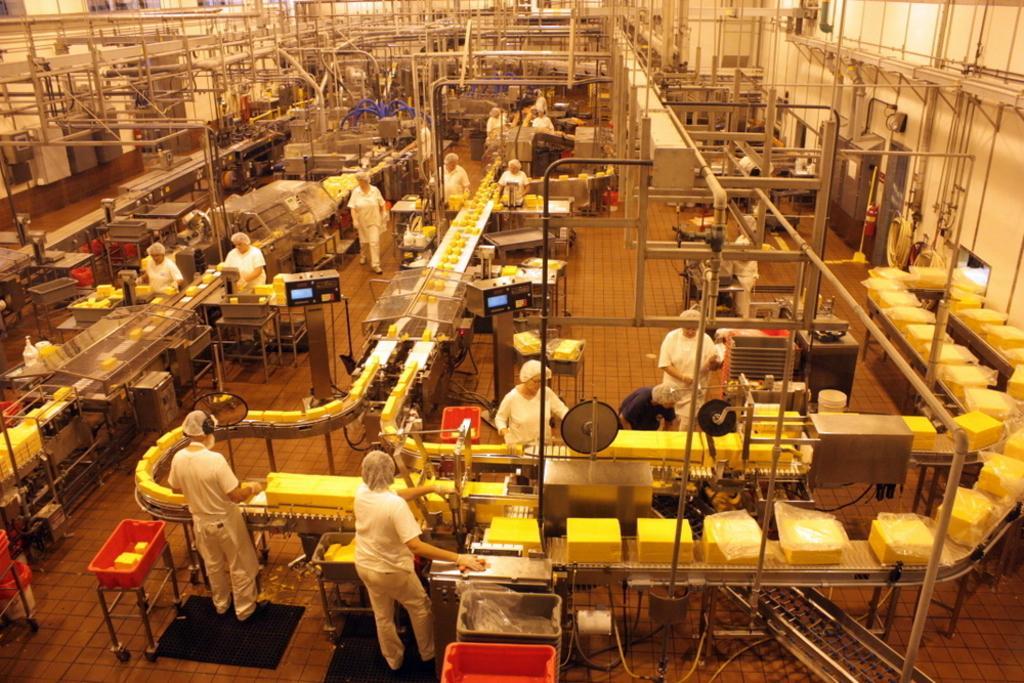Describe this image in one or two sentences. In the picture I can see the cheese factory as I can see the pipelines arrangement. I can see the stock boxes on the conveyor belts. In the picture I can see a few persons and they are working. 